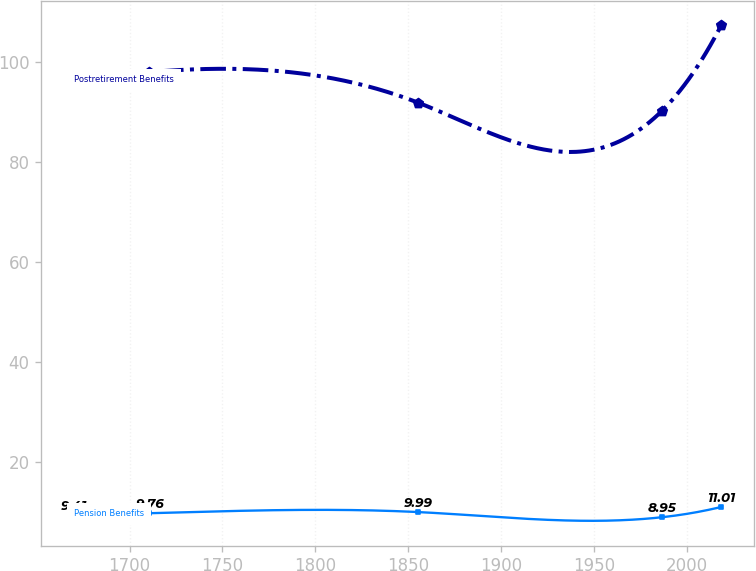<chart> <loc_0><loc_0><loc_500><loc_500><line_chart><ecel><fcel>Postretirement Benefits<fcel>Pension Benefits<nl><fcel>1669.96<fcel>96.21<fcel>9.41<nl><fcel>1710.68<fcel>97.93<fcel>9.76<nl><fcel>1855.38<fcel>91.83<fcel>9.99<nl><fcel>1986.41<fcel>90.11<fcel>8.95<nl><fcel>2018.52<fcel>107.28<fcel>11.01<nl></chart> 